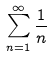Convert formula to latex. <formula><loc_0><loc_0><loc_500><loc_500>\sum _ { n = 1 } ^ { \infty } \frac { 1 } { n }</formula> 